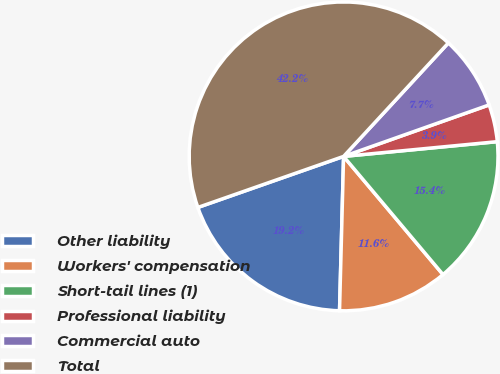Convert chart. <chart><loc_0><loc_0><loc_500><loc_500><pie_chart><fcel>Other liability<fcel>Workers' compensation<fcel>Short-tail lines (1)<fcel>Professional liability<fcel>Commercial auto<fcel>Total<nl><fcel>19.22%<fcel>11.55%<fcel>15.39%<fcel>3.89%<fcel>7.72%<fcel>42.23%<nl></chart> 